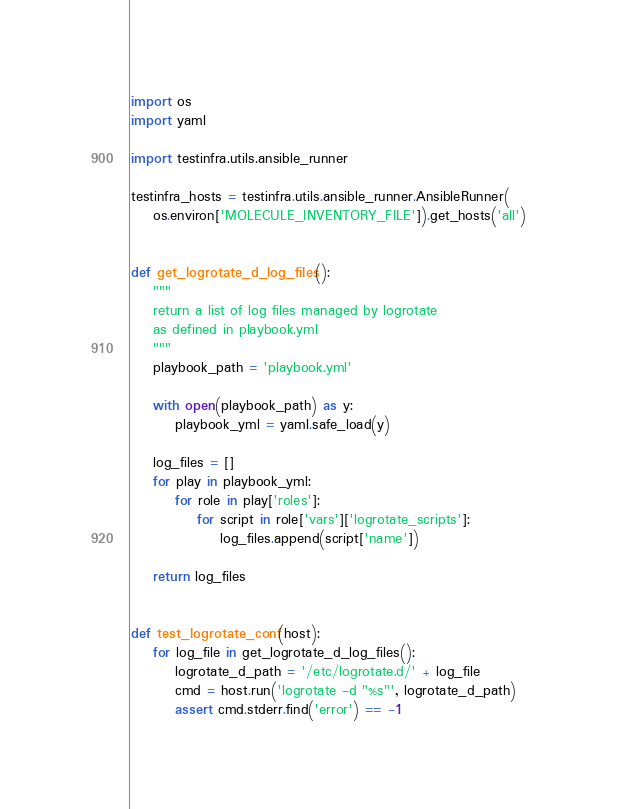Convert code to text. <code><loc_0><loc_0><loc_500><loc_500><_Python_>import os
import yaml

import testinfra.utils.ansible_runner

testinfra_hosts = testinfra.utils.ansible_runner.AnsibleRunner(
    os.environ['MOLECULE_INVENTORY_FILE']).get_hosts('all')


def get_logrotate_d_log_files():
    """
    return a list of log files managed by logrotate
    as defined in playbook.yml
    """
    playbook_path = 'playbook.yml'

    with open(playbook_path) as y:
        playbook_yml = yaml.safe_load(y)

    log_files = []
    for play in playbook_yml:
        for role in play['roles']:
            for script in role['vars']['logrotate_scripts']:
                log_files.append(script['name'])

    return log_files


def test_logrotate_conf(host):
    for log_file in get_logrotate_d_log_files():
        logrotate_d_path = '/etc/logrotate.d/' + log_file
        cmd = host.run('logrotate -d "%s"', logrotate_d_path)
        assert cmd.stderr.find('error') == -1
</code> 